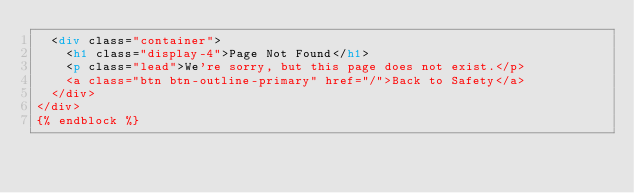Convert code to text. <code><loc_0><loc_0><loc_500><loc_500><_HTML_>  <div class="container">
    <h1 class="display-4">Page Not Found</h1>
    <p class="lead">We're sorry, but this page does not exist.</p>
    <a class="btn btn-outline-primary" href="/">Back to Safety</a>
  </div>
</div>
{% endblock %}</code> 